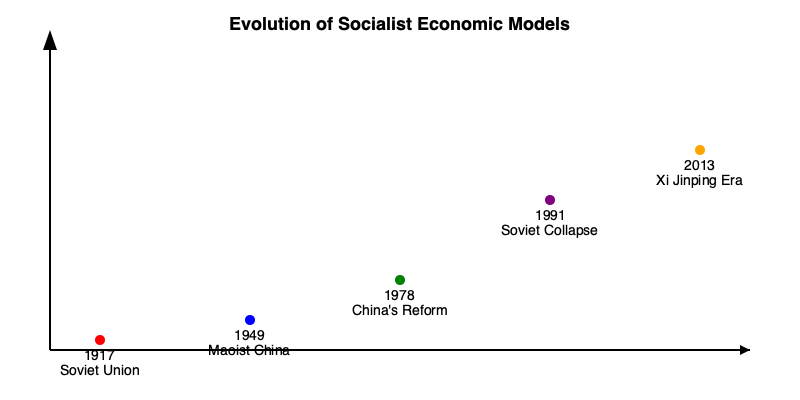Based on the timeline infographic, which event marked the most significant shift towards economic liberalization in socialist systems, and how did it impact the global perception of socialist economic models? To answer this question, we need to analyze the events depicted in the timeline:

1. 1917 - Soviet Union: This marks the beginning of the first large-scale socialist experiment, with a centrally planned economy.

2. 1949 - Maoist China: Another major socialist state emerges, following a similar centrally planned model.

3. 1978 - China's Reform: This represents a significant shift. Deng Xiaoping initiated market-oriented reforms, introducing elements of capitalism into China's socialist system.

4. 1991 - Soviet Collapse: The dissolution of the USSR marked the end of the original socialist experiment and led to rapid privatization in former Soviet states.

5. 2013 - Xi Jinping Era: Represents a slight pullback from market reforms, with more state intervention in the economy.

The most significant shift towards economic liberalization is China's 1978 Reform. This event is crucial because:

a) It introduced market elements into a major socialist economy for the first time.
b) It led to rapid economic growth, demonstrating that socialist systems could incorporate market mechanisms.
c) It influenced other socialist countries to consider similar reforms.
d) It changed the global perception of socialist economic models, showing they could be flexible and adapt to market principles.

The impact on global perception was profound. The success of China's economic reforms challenged the binary view of capitalism vs. socialism, introducing the concept of a "socialist market economy." This hybrid model influenced economic thinking worldwide and prompted discussions about the viability of mixed economic systems in both socialist and capitalist countries.
Answer: China's 1978 Reform; it introduced market elements into socialism, demonstrating adaptability and influencing global economic thought. 